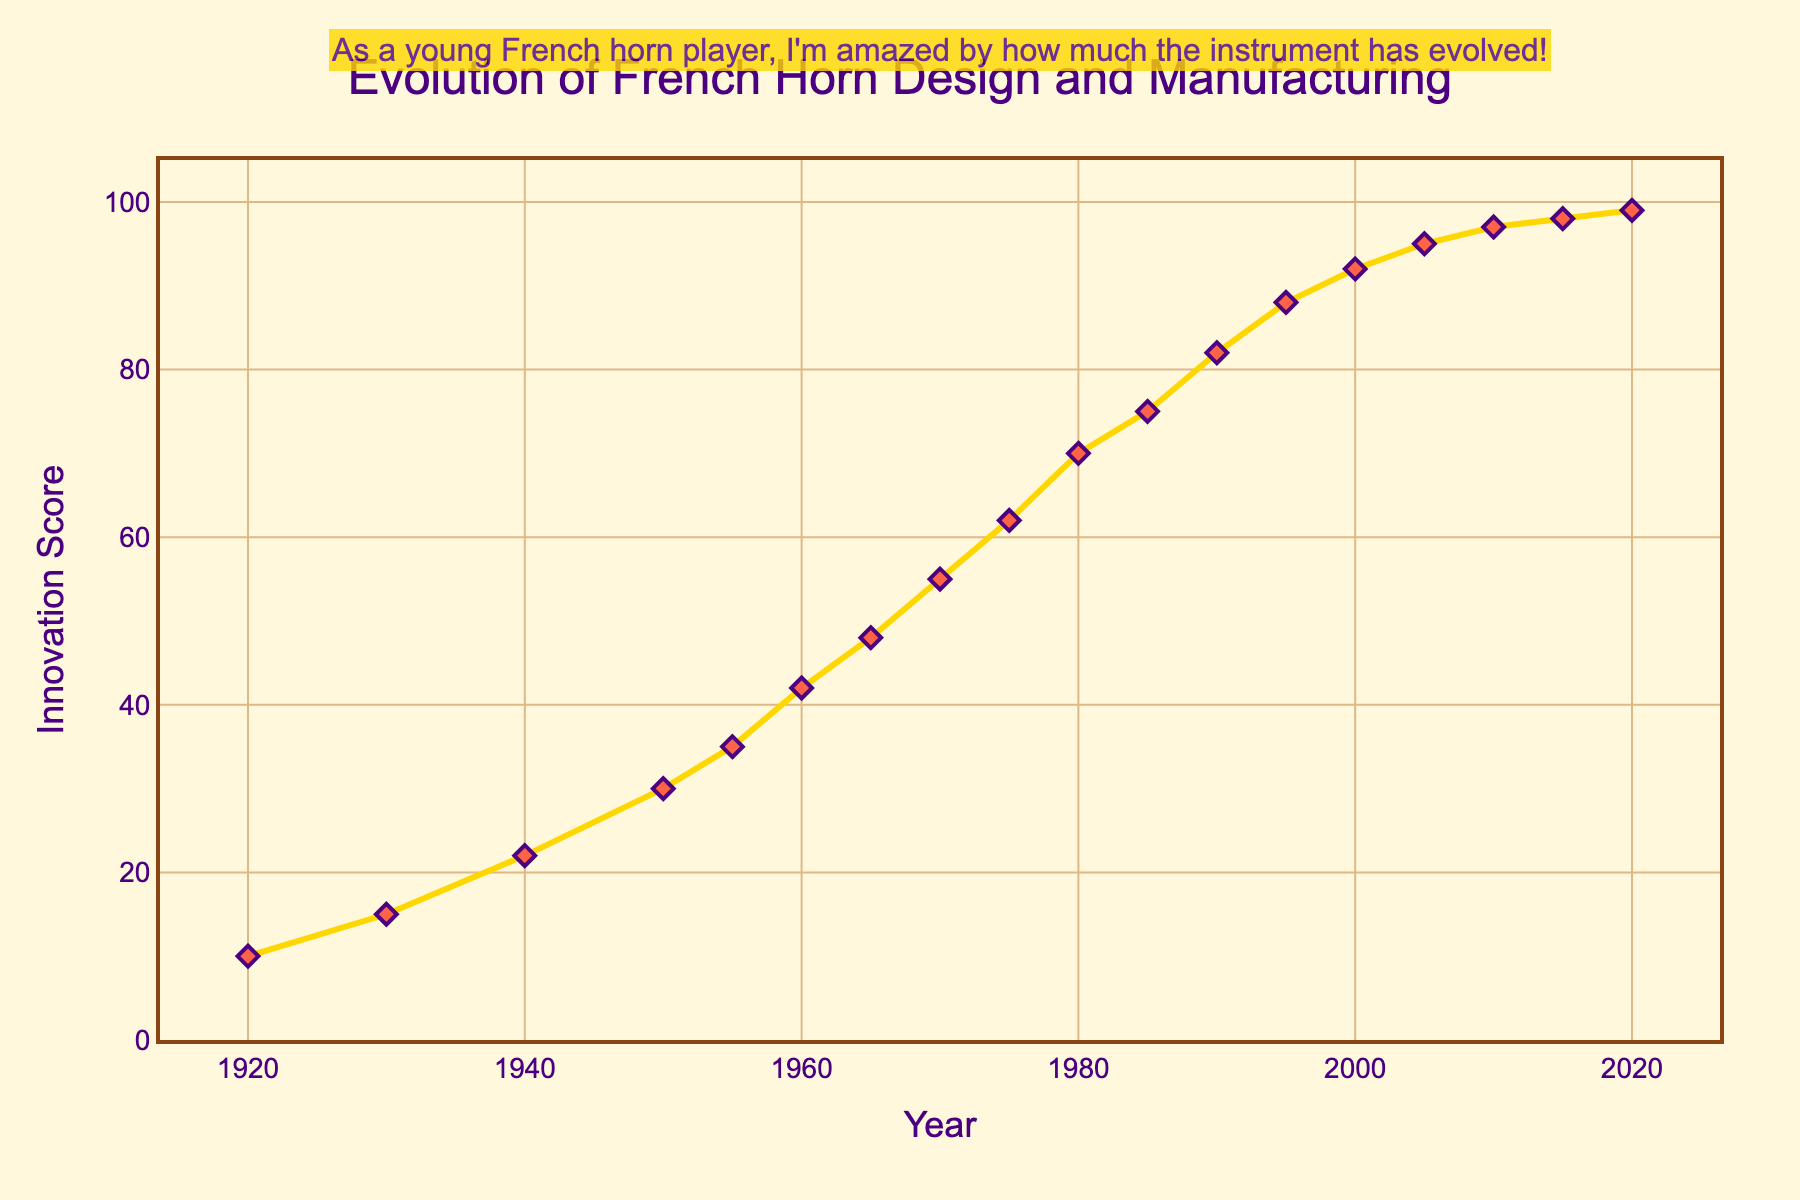What is the difference in Innovation Score between the years 1920 and 2020? To determine the difference, subtract the Innovation Score of 1920 (10) from that of 2020 (99): 99 - 10
Answer: 89 Which year shows the greatest increase in Innovation Score compared to the previous year? To find the year with the greatest increase, examine the differences in Innovation Scores year by year: 1930 increases by 5, 1940 by 7, 1950 by 8, and so forth. The largest jump is from 1975 to 1980, where the score increases from 62 to 70 (an increase of 8).
Answer: 1975-1980 What is the average Innovation Score between 1950 and 2000? To calculate the average, sum the Innovation Scores from 1950 (30), 1955 (35), 1960 (42), 1965 (48), 1970 (55), 1975 (62), 1980 (70), 1985 (75), 1990 (82), 1995 (88), and 2000 (92). The sum is 679. The number of values is 11. The average is 679/11.
Answer: 61.73 What visual characteristics are used to differentiate data points on the chart? The data points are marked with diamond shapes that are red, and they also have an outer line that is a different color. The markers have a size of 8 and an outline width of 2.
Answer: Diamond shapes and colors In which decade does the Innovation Score first surpass 50? To answer this, look at the Innovation Score by decade: In the 1960s, the score is 42 and 48, and in the 1970s, it is 55 in 1970. The first surpassing happens in 1970.
Answer: 1970 What is the trend of the Innovation Score between 2000 and 2020? To identify the trend, observe the scores: 2000 (92), 2005 (95), 2010 (97), 2015 (98), and 2020 (99). The scores gradually increase over this period.
Answer: Gradual increase Which year has an Innovation Score exactly halfway between the scores of 1920 and 2020? The score in 1920 is 10 and in 2020 it is 99. Halfway is (99 + 10) / 2 = 54.5. Checking the scores, 1970 has the closest score to 54.5, with a score of 55.
Answer: 1970 How much did the Innovation Score increase between 1940 and 1950? To calculate the increase, subtract the 1940 Innovation Score (22) from the 1950 score (30): 30 - 22
Answer: 8 Which year closely follows a linear increase trend in Innovation Score from 1960 to 1980? To determine this, check the scores: 1960 (42), 1965 (48), 1970 (55), 1975 (62), and 1980 (70). Each period has relatively consistent increments, approximately 6-7 points.
Answer: 1975 